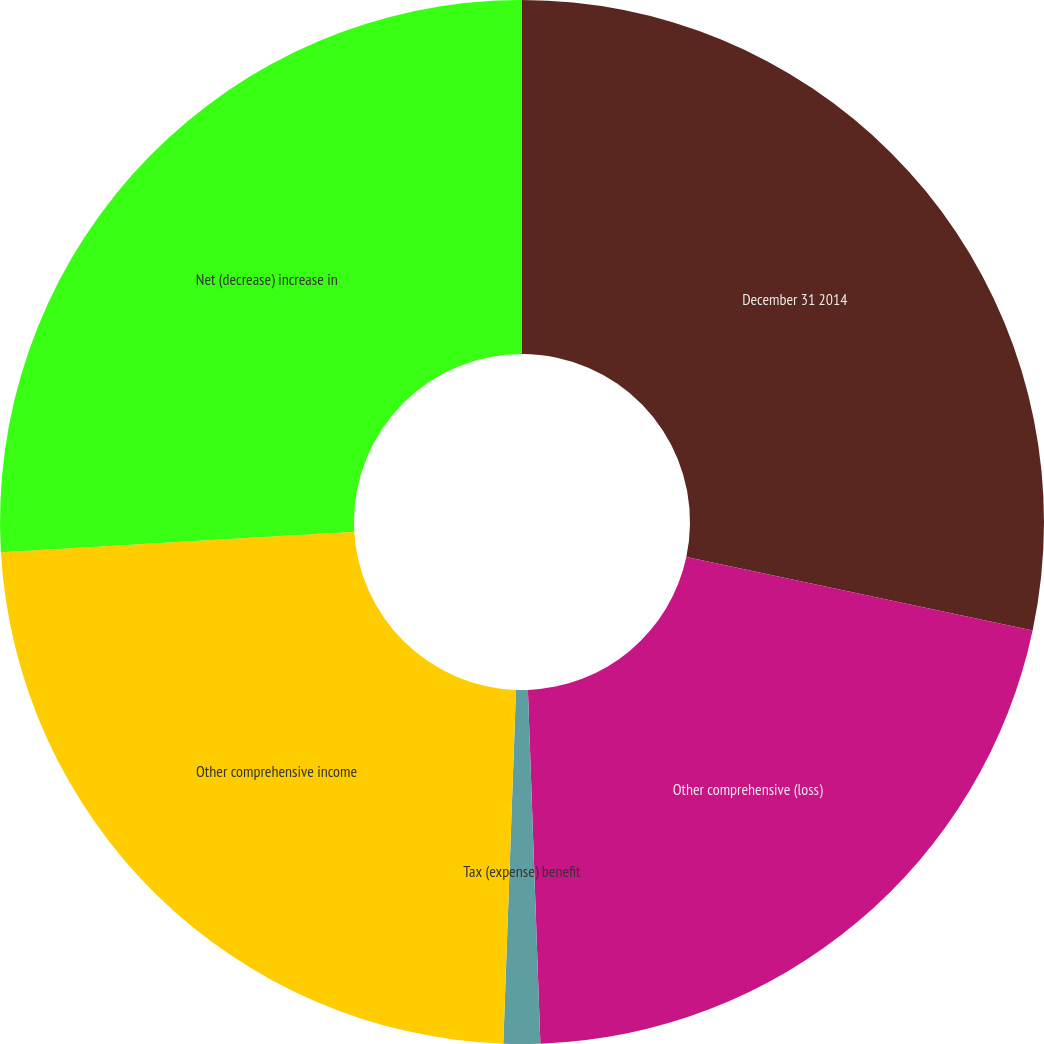Convert chart to OTSL. <chart><loc_0><loc_0><loc_500><loc_500><pie_chart><fcel>December 31 2014<fcel>Other comprehensive (loss)<fcel>Tax (expense) benefit<fcel>Other comprehensive income<fcel>Net (decrease) increase in<nl><fcel>28.33%<fcel>21.11%<fcel>1.13%<fcel>23.51%<fcel>25.92%<nl></chart> 